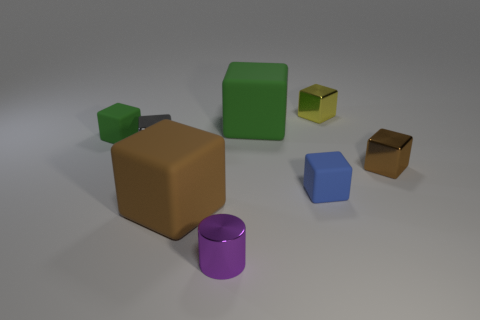Subtract all large green cubes. How many cubes are left? 6 Add 1 green metallic blocks. How many objects exist? 9 Subtract all gray blocks. How many blocks are left? 6 Subtract all cubes. How many objects are left? 1 Subtract all red spheres. How many gray blocks are left? 1 Subtract all brown objects. Subtract all small gray shiny things. How many objects are left? 5 Add 8 tiny brown shiny cubes. How many tiny brown shiny cubes are left? 9 Add 3 tiny gray blocks. How many tiny gray blocks exist? 4 Subtract 0 yellow balls. How many objects are left? 8 Subtract 5 blocks. How many blocks are left? 2 